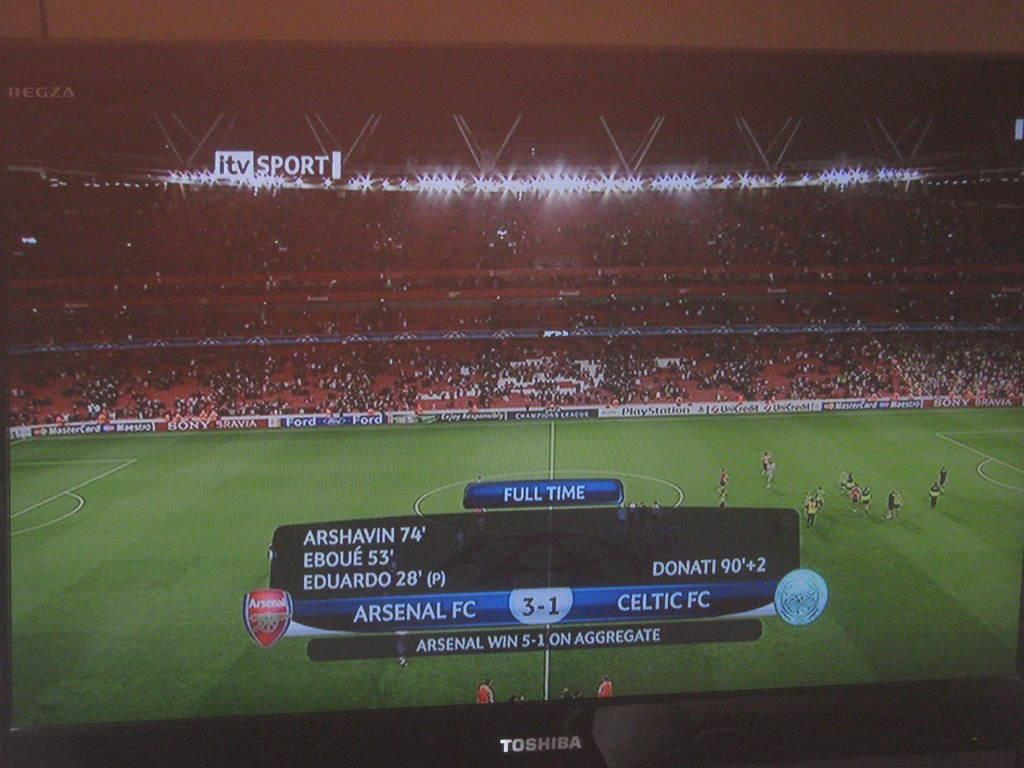<image>
Describe the image concisely. A graphic on the screen states Arsenal wins 5-1. 